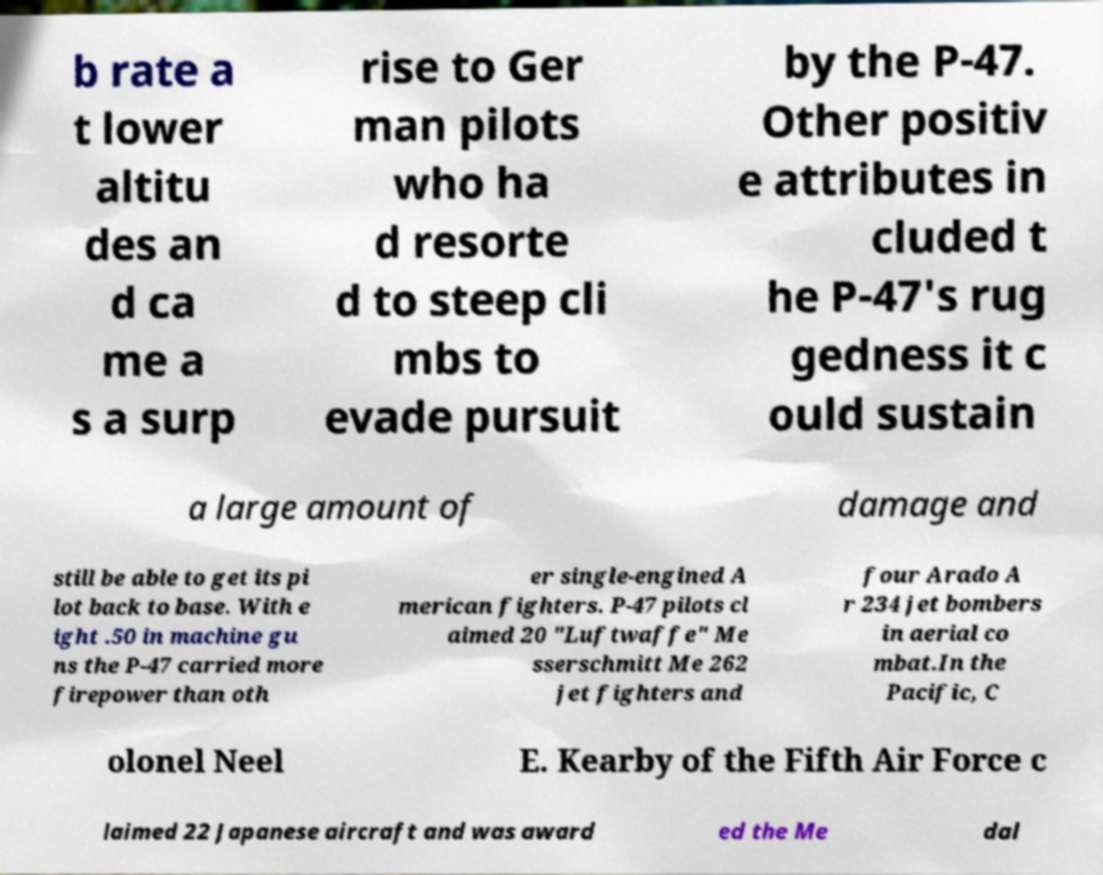I need the written content from this picture converted into text. Can you do that? b rate a t lower altitu des an d ca me a s a surp rise to Ger man pilots who ha d resorte d to steep cli mbs to evade pursuit by the P-47. Other positiv e attributes in cluded t he P-47's rug gedness it c ould sustain a large amount of damage and still be able to get its pi lot back to base. With e ight .50 in machine gu ns the P-47 carried more firepower than oth er single-engined A merican fighters. P-47 pilots cl aimed 20 "Luftwaffe" Me sserschmitt Me 262 jet fighters and four Arado A r 234 jet bombers in aerial co mbat.In the Pacific, C olonel Neel E. Kearby of the Fifth Air Force c laimed 22 Japanese aircraft and was award ed the Me dal 